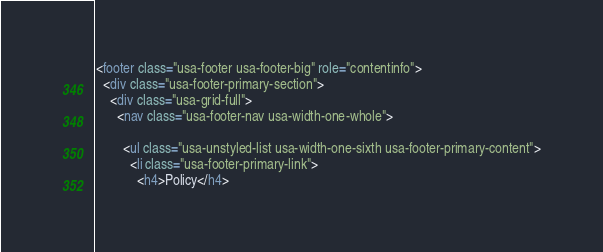Convert code to text. <code><loc_0><loc_0><loc_500><loc_500><_HTML_><footer class="usa-footer usa-footer-big" role="contentinfo">
  <div class="usa-footer-primary-section">
    <div class="usa-grid-full">
      <nav class="usa-footer-nav usa-width-one-whole">

        <ul class="usa-unstyled-list usa-width-one-sixth usa-footer-primary-content">
          <li class="usa-footer-primary-link">
            <h4>Policy</h4></code> 